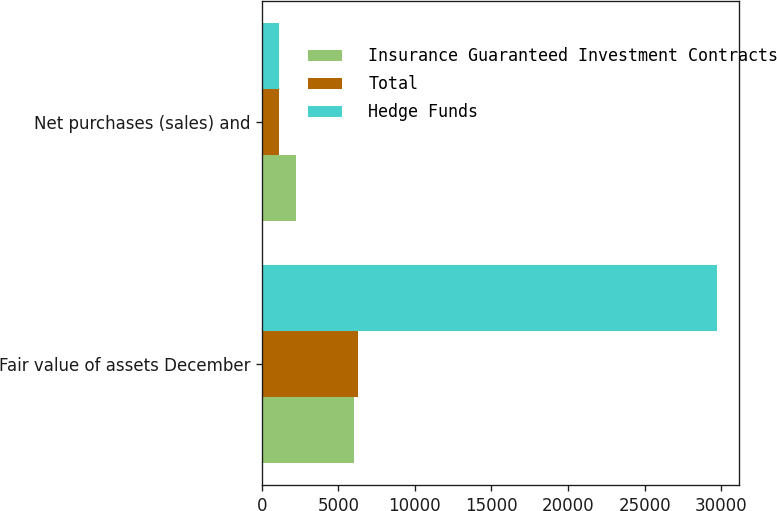<chart> <loc_0><loc_0><loc_500><loc_500><stacked_bar_chart><ecel><fcel>Fair value of assets December<fcel>Net purchases (sales) and<nl><fcel>Insurance Guaranteed Investment Contracts<fcel>6018<fcel>2262<nl><fcel>Total<fcel>6266<fcel>1136<nl><fcel>Hedge Funds<fcel>29697<fcel>1126<nl></chart> 